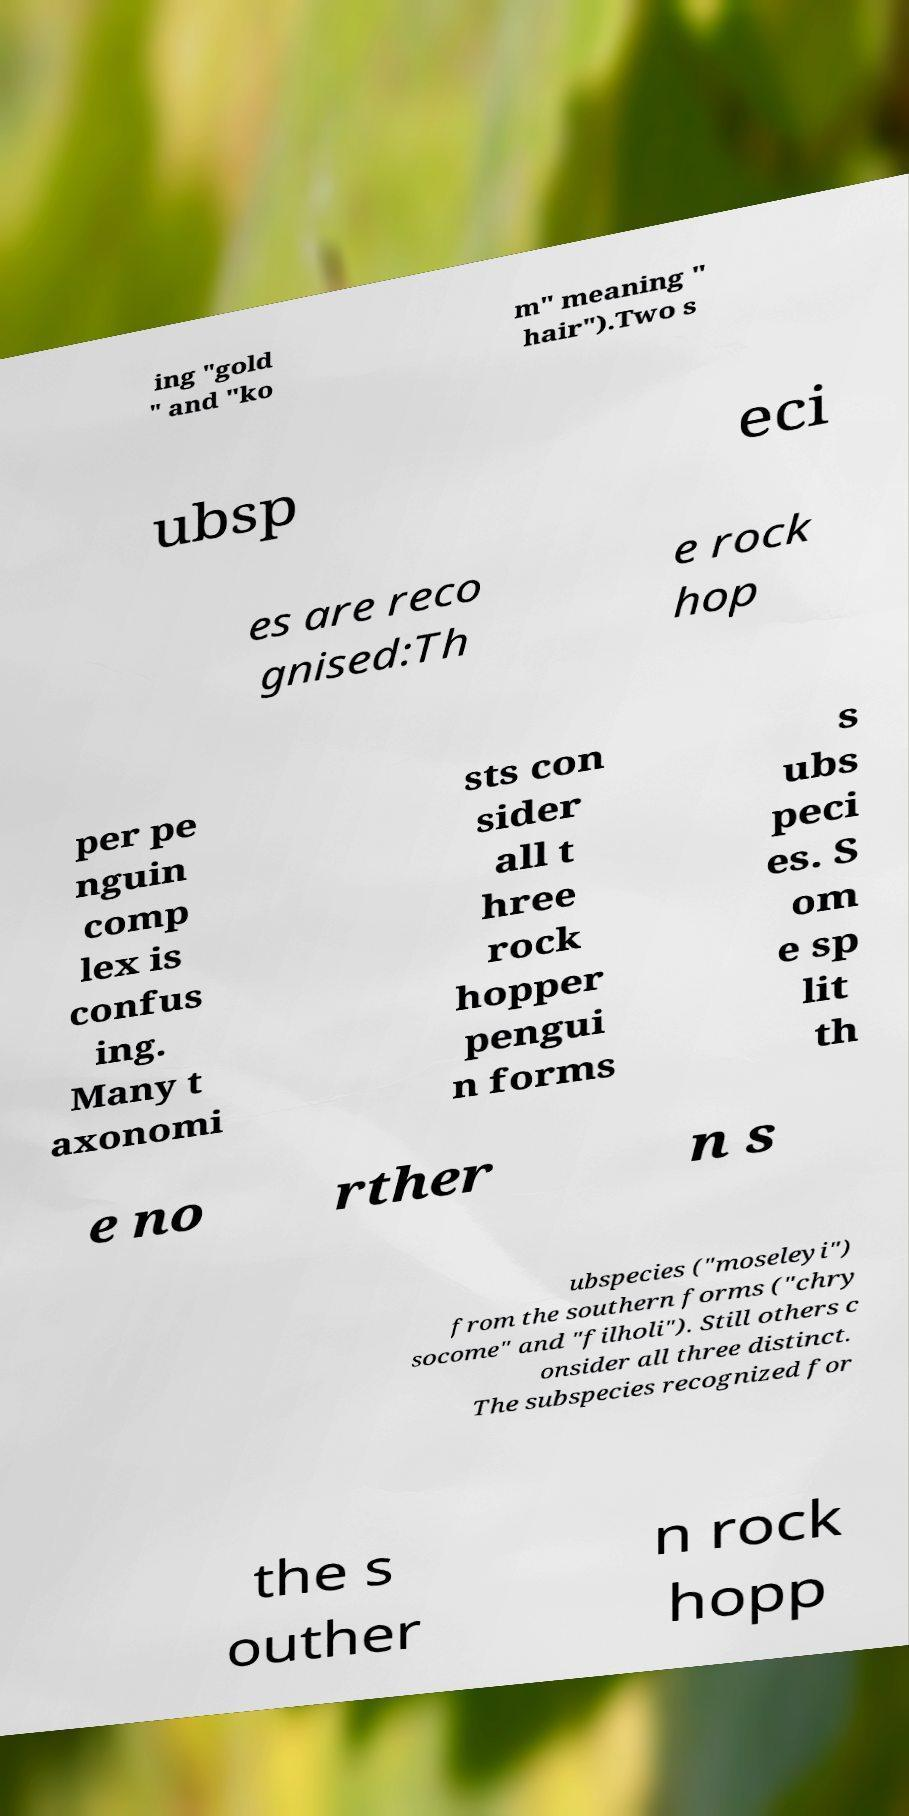Please identify and transcribe the text found in this image. ing "gold " and "ko m" meaning " hair").Two s ubsp eci es are reco gnised:Th e rock hop per pe nguin comp lex is confus ing. Many t axonomi sts con sider all t hree rock hopper pengui n forms s ubs peci es. S om e sp lit th e no rther n s ubspecies ("moseleyi") from the southern forms ("chry socome" and "filholi"). Still others c onsider all three distinct. The subspecies recognized for the s outher n rock hopp 